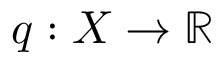Convert formula to latex. <formula><loc_0><loc_0><loc_500><loc_500>q \colon X \to \mathbb { R }</formula> 